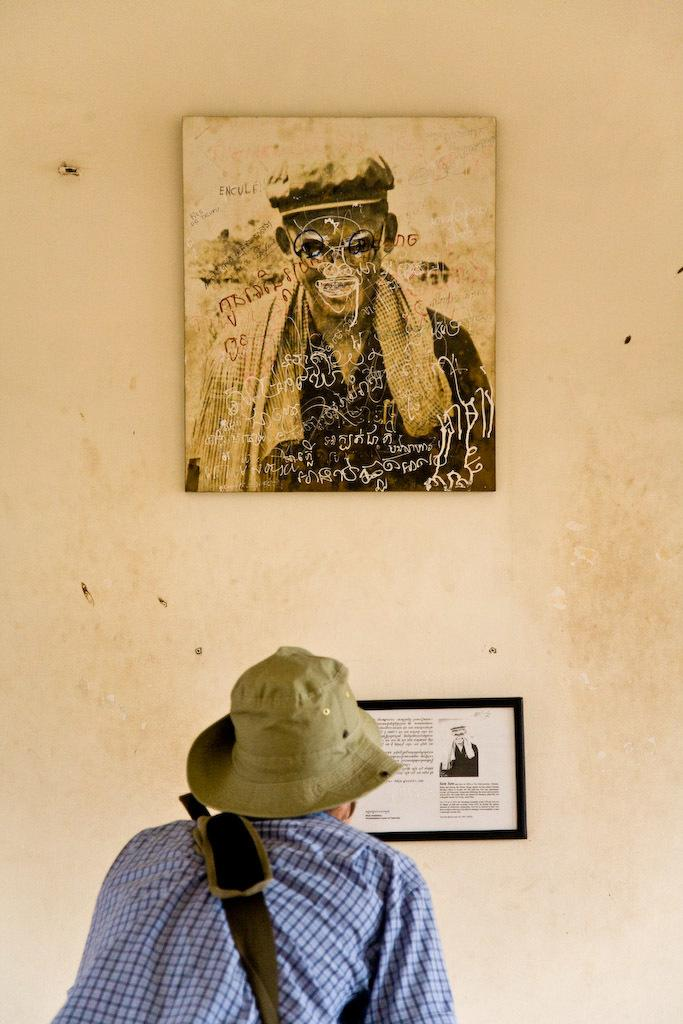Who or what is the main subject in the image? There is a person in the image. Can you describe the person's attire? The person is wearing a hat. What can be seen on the wall in the image? There are photo frames on the wall. What is inside the photo frames? There is text in the photo frames. How many legs can be seen on the table in the image? There is no table present in the image, so it is not possible to determine the number of legs. 